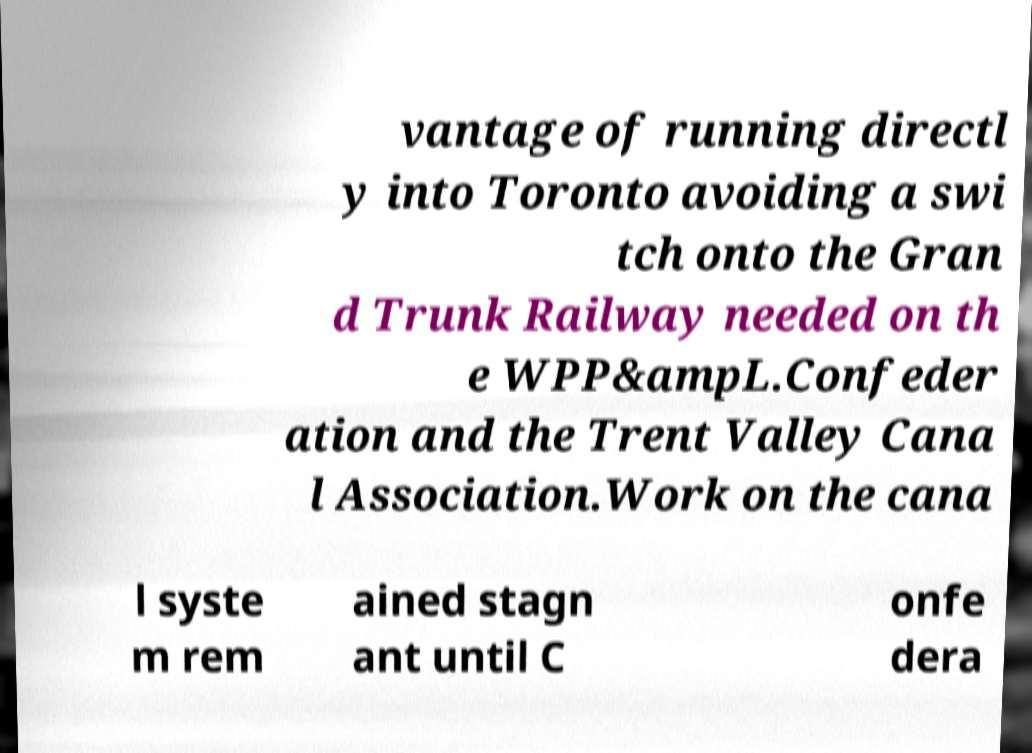What messages or text are displayed in this image? I need them in a readable, typed format. vantage of running directl y into Toronto avoiding a swi tch onto the Gran d Trunk Railway needed on th e WPP&ampL.Confeder ation and the Trent Valley Cana l Association.Work on the cana l syste m rem ained stagn ant until C onfe dera 